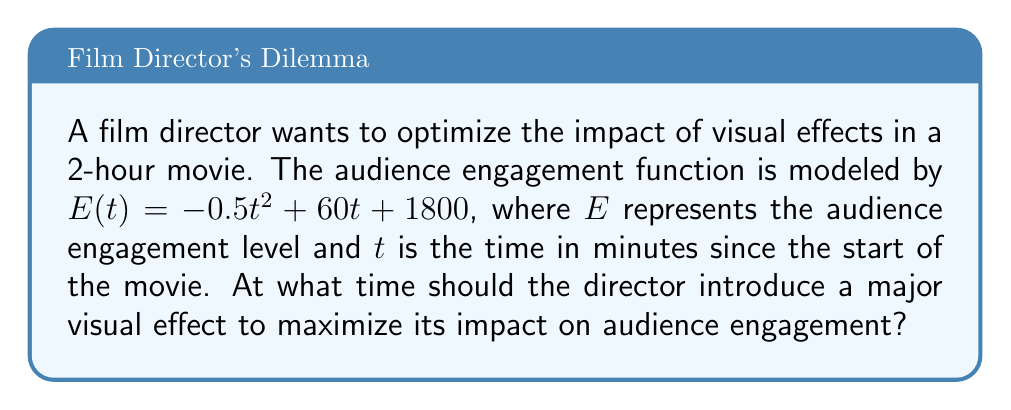Could you help me with this problem? To solve this problem, we need to find the maximum point of the audience engagement function $E(t)$. This can be done using calculus by following these steps:

1) First, we need to find the derivative of $E(t)$ with respect to $t$:

   $$\frac{dE}{dt} = -t + 60$$

2) To find the maximum point, we set the derivative equal to zero and solve for $t$:

   $$-t + 60 = 0$$
   $$-t = -60$$
   $$t = 60$$

3) To confirm this is a maximum (not a minimum), we can check the second derivative:

   $$\frac{d^2E}{dt^2} = -1$$

   Since the second derivative is negative, we confirm that $t = 60$ gives us a maximum.

4) Therefore, the audience engagement is at its peak 60 minutes into the movie.

5) To convert this to hours for a more intuitive understanding:

   $$60 \text{ minutes} = 1 \text{ hour}$$

Thus, the optimal time to introduce a major visual effect to maximize its impact on audience engagement is 1 hour into the 2-hour movie.
Answer: The optimal time to introduce a major visual effect is 60 minutes (1 hour) into the movie. 